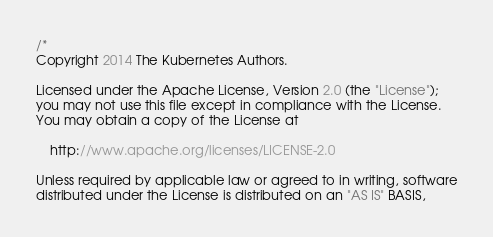<code> <loc_0><loc_0><loc_500><loc_500><_Go_>/*
Copyright 2014 The Kubernetes Authors.

Licensed under the Apache License, Version 2.0 (the "License");
you may not use this file except in compliance with the License.
You may obtain a copy of the License at

    http://www.apache.org/licenses/LICENSE-2.0

Unless required by applicable law or agreed to in writing, software
distributed under the License is distributed on an "AS IS" BASIS,</code> 